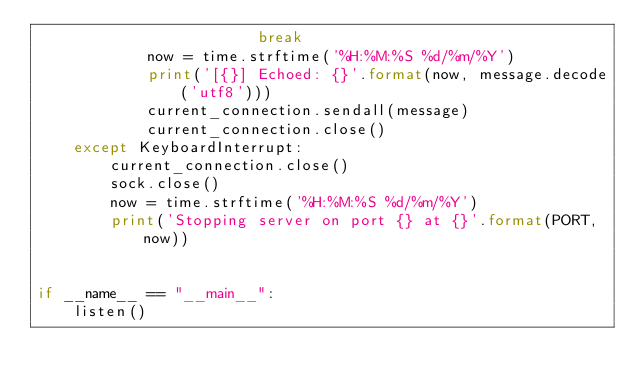Convert code to text. <code><loc_0><loc_0><loc_500><loc_500><_Python_>                        break
            now = time.strftime('%H:%M:%S %d/%m/%Y')
            print('[{}] Echoed: {}'.format(now, message.decode('utf8')))
            current_connection.sendall(message)
            current_connection.close()
    except KeyboardInterrupt:
        current_connection.close()
        sock.close()
        now = time.strftime('%H:%M:%S %d/%m/%Y')
        print('Stopping server on port {} at {}'.format(PORT, now))


if __name__ == "__main__":
    listen()
</code> 